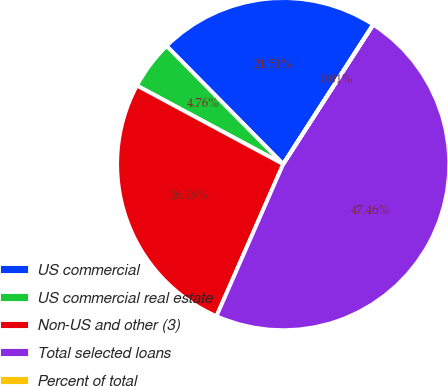Convert chart. <chart><loc_0><loc_0><loc_500><loc_500><pie_chart><fcel>US commercial<fcel>US commercial real estate<fcel>Non-US and other (3)<fcel>Total selected loans<fcel>Percent of total<nl><fcel>21.51%<fcel>4.76%<fcel>26.26%<fcel>47.46%<fcel>0.01%<nl></chart> 